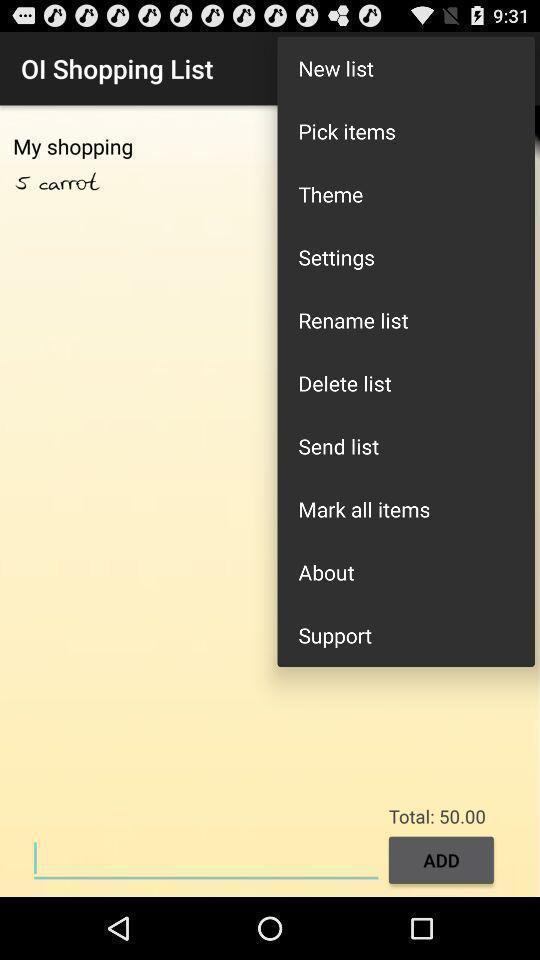Provide a textual representation of this image. Page with different options of a shopping app. 